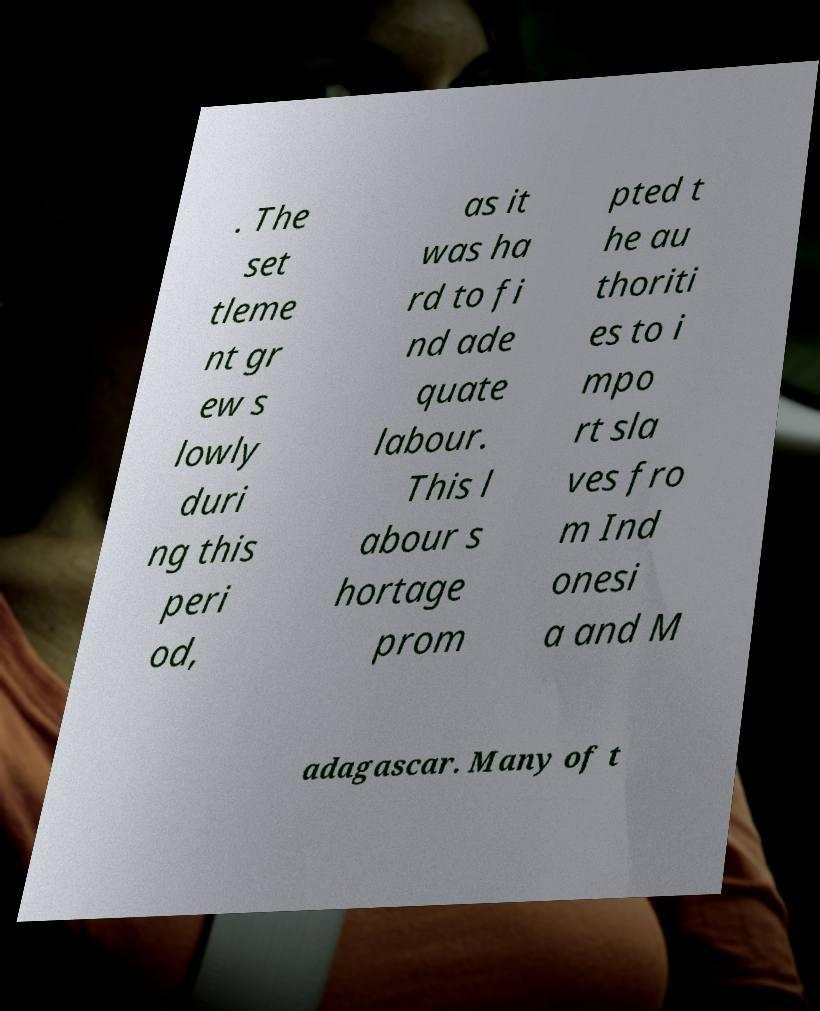Could you extract and type out the text from this image? . The set tleme nt gr ew s lowly duri ng this peri od, as it was ha rd to fi nd ade quate labour. This l abour s hortage prom pted t he au thoriti es to i mpo rt sla ves fro m Ind onesi a and M adagascar. Many of t 